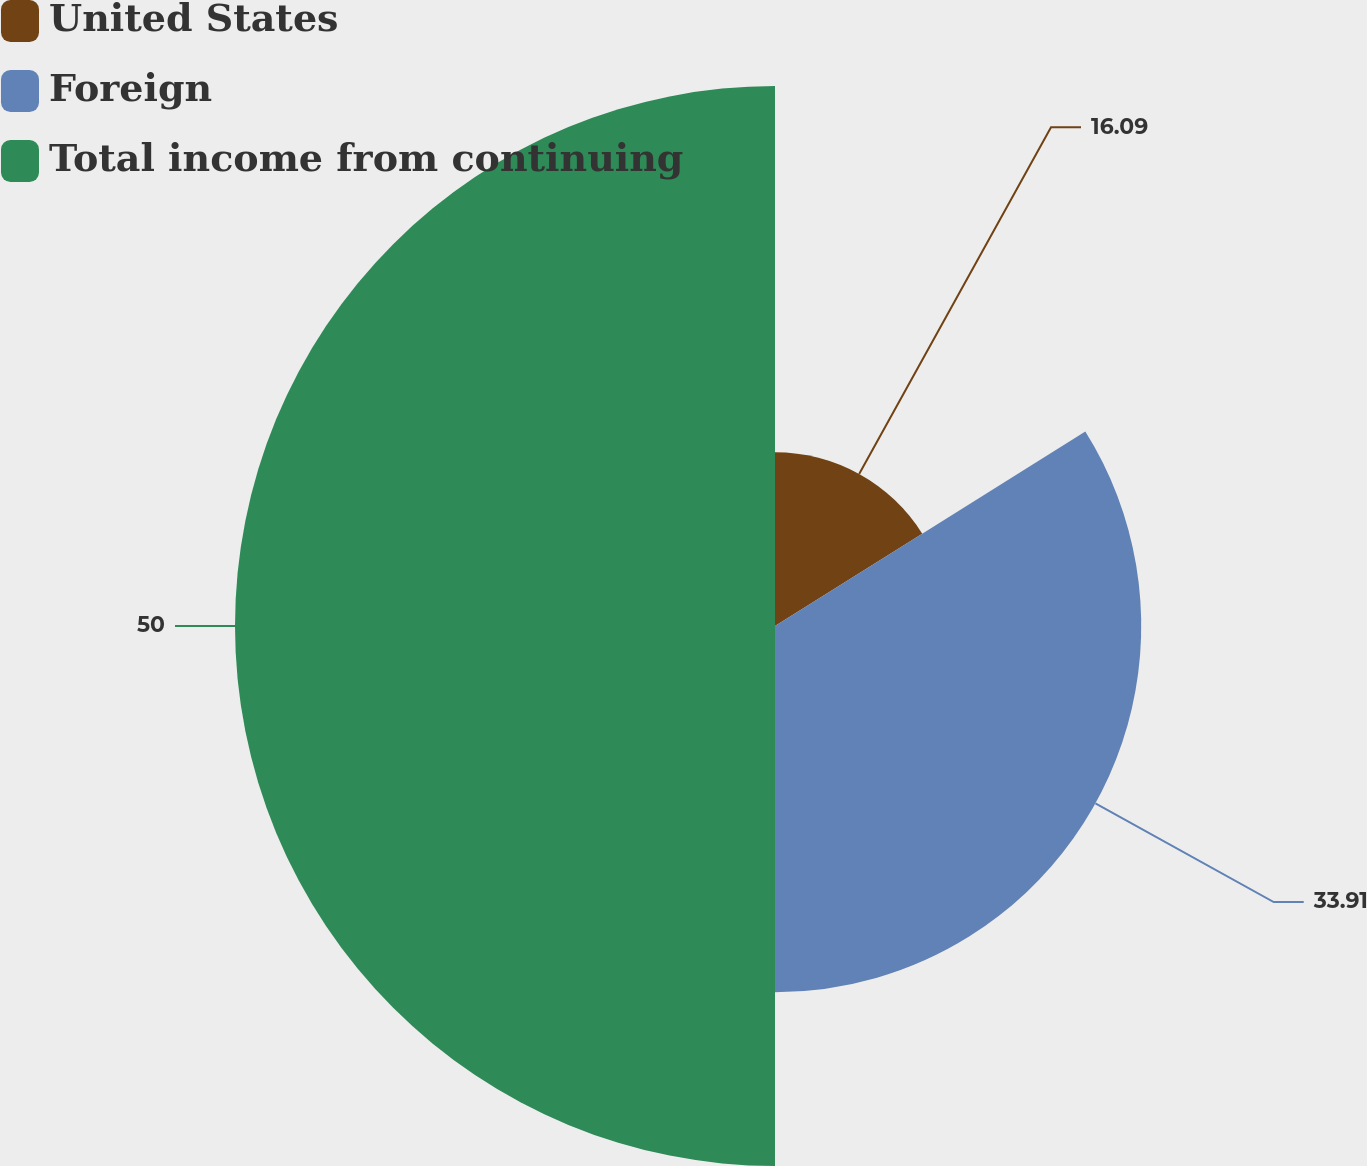Convert chart. <chart><loc_0><loc_0><loc_500><loc_500><pie_chart><fcel>United States<fcel>Foreign<fcel>Total income from continuing<nl><fcel>16.09%<fcel>33.91%<fcel>50.0%<nl></chart> 